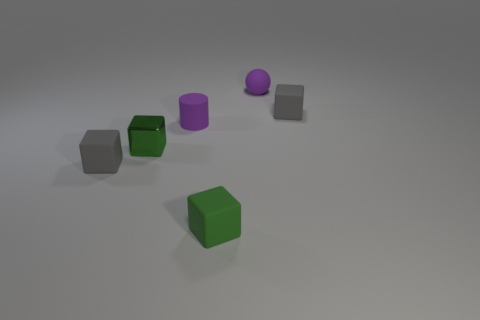Subtract all brown cubes. Subtract all yellow cylinders. How many cubes are left? 4 Add 1 small rubber spheres. How many objects exist? 7 Subtract all balls. How many objects are left? 5 Subtract all big cyan shiny cubes. Subtract all tiny purple rubber cylinders. How many objects are left? 5 Add 1 spheres. How many spheres are left? 2 Add 3 big yellow cylinders. How many big yellow cylinders exist? 3 Subtract 0 brown cubes. How many objects are left? 6 